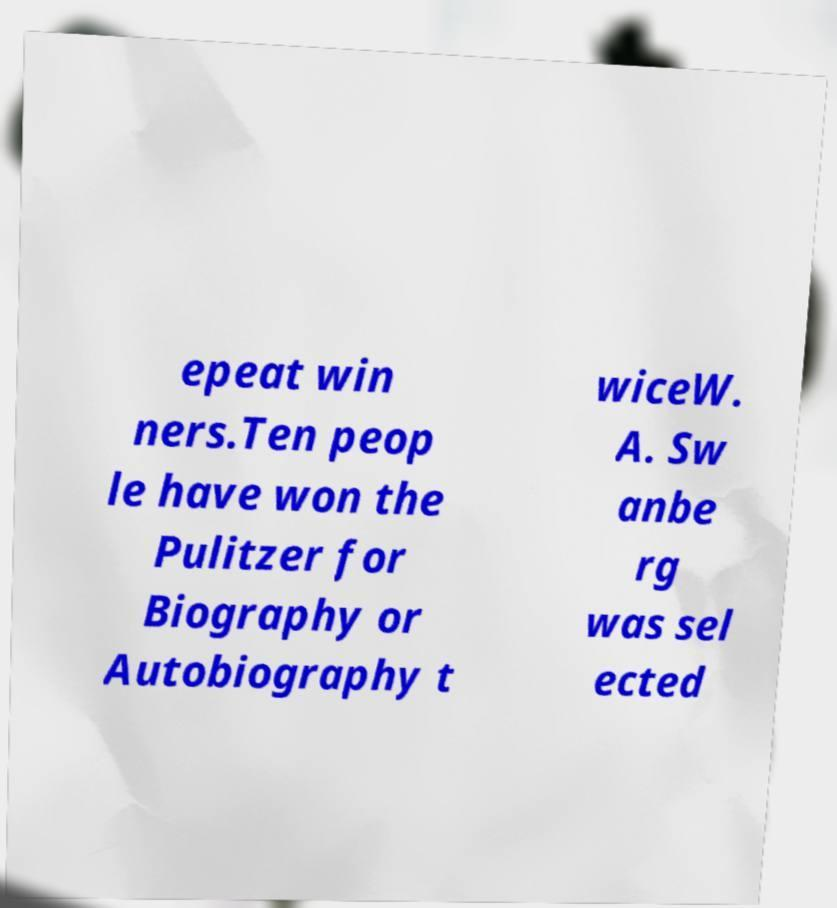Could you assist in decoding the text presented in this image and type it out clearly? epeat win ners.Ten peop le have won the Pulitzer for Biography or Autobiography t wiceW. A. Sw anbe rg was sel ected 